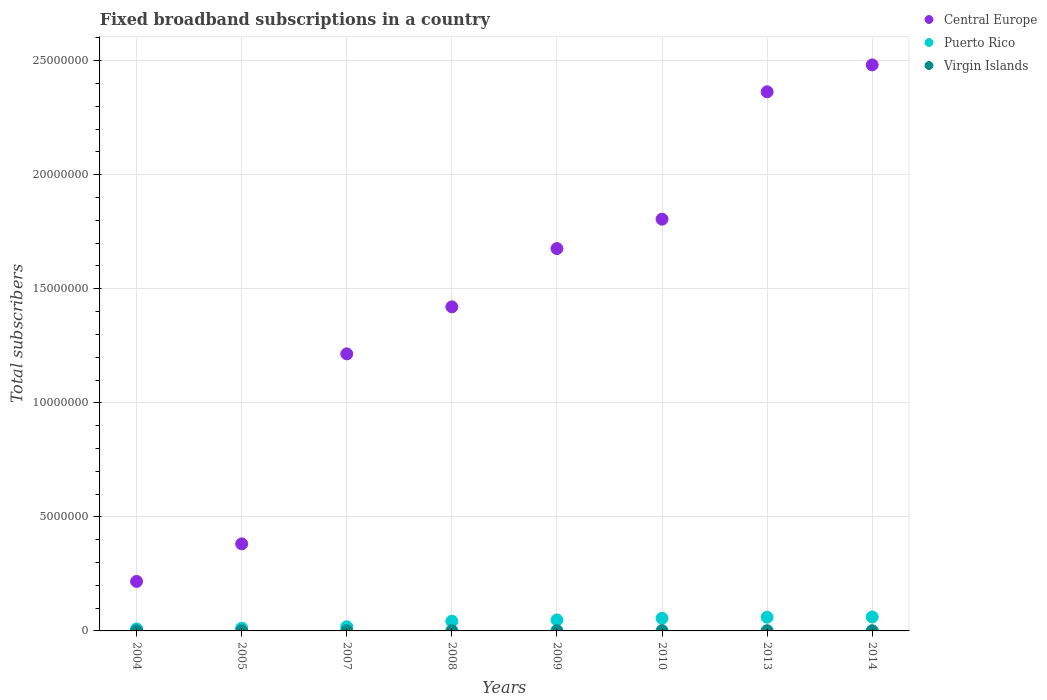Is the number of dotlines equal to the number of legend labels?
Keep it short and to the point. Yes. What is the number of broadband subscriptions in Central Europe in 2009?
Give a very brief answer. 1.68e+07. Across all years, what is the maximum number of broadband subscriptions in Virgin Islands?
Your answer should be compact. 9100. Across all years, what is the minimum number of broadband subscriptions in Central Europe?
Your answer should be compact. 2.17e+06. In which year was the number of broadband subscriptions in Puerto Rico maximum?
Ensure brevity in your answer.  2014. What is the total number of broadband subscriptions in Virgin Islands in the graph?
Ensure brevity in your answer.  5.41e+04. What is the difference between the number of broadband subscriptions in Virgin Islands in 2008 and that in 2009?
Your response must be concise. -1584. What is the difference between the number of broadband subscriptions in Central Europe in 2013 and the number of broadband subscriptions in Virgin Islands in 2007?
Make the answer very short. 2.36e+07. What is the average number of broadband subscriptions in Puerto Rico per year?
Your answer should be very brief. 3.82e+05. In the year 2004, what is the difference between the number of broadband subscriptions in Puerto Rico and number of broadband subscriptions in Central Europe?
Provide a short and direct response. -2.08e+06. In how many years, is the number of broadband subscriptions in Central Europe greater than 13000000?
Your answer should be compact. 5. What is the ratio of the number of broadband subscriptions in Virgin Islands in 2005 to that in 2008?
Provide a succinct answer. 0.4. Is the number of broadband subscriptions in Puerto Rico in 2007 less than that in 2014?
Ensure brevity in your answer.  Yes. Is the difference between the number of broadband subscriptions in Puerto Rico in 2009 and 2010 greater than the difference between the number of broadband subscriptions in Central Europe in 2009 and 2010?
Provide a succinct answer. Yes. What is the difference between the highest and the second highest number of broadband subscriptions in Central Europe?
Ensure brevity in your answer.  1.18e+06. What is the difference between the highest and the lowest number of broadband subscriptions in Virgin Islands?
Keep it short and to the point. 7616. In how many years, is the number of broadband subscriptions in Puerto Rico greater than the average number of broadband subscriptions in Puerto Rico taken over all years?
Your answer should be very brief. 5. Is it the case that in every year, the sum of the number of broadband subscriptions in Puerto Rico and number of broadband subscriptions in Central Europe  is greater than the number of broadband subscriptions in Virgin Islands?
Keep it short and to the point. Yes. Does the number of broadband subscriptions in Virgin Islands monotonically increase over the years?
Provide a succinct answer. No. Is the number of broadband subscriptions in Central Europe strictly greater than the number of broadband subscriptions in Puerto Rico over the years?
Offer a very short reply. Yes. Are the values on the major ticks of Y-axis written in scientific E-notation?
Your answer should be very brief. No. Does the graph contain grids?
Offer a terse response. Yes. How are the legend labels stacked?
Keep it short and to the point. Vertical. What is the title of the graph?
Make the answer very short. Fixed broadband subscriptions in a country. Does "Ireland" appear as one of the legend labels in the graph?
Keep it short and to the point. No. What is the label or title of the X-axis?
Your response must be concise. Years. What is the label or title of the Y-axis?
Make the answer very short. Total subscribers. What is the Total subscribers of Central Europe in 2004?
Your answer should be compact. 2.17e+06. What is the Total subscribers of Puerto Rico in 2004?
Your answer should be very brief. 8.63e+04. What is the Total subscribers of Virgin Islands in 2004?
Provide a short and direct response. 1484. What is the Total subscribers of Central Europe in 2005?
Make the answer very short. 3.82e+06. What is the Total subscribers of Puerto Rico in 2005?
Ensure brevity in your answer.  1.18e+05. What is the Total subscribers in Virgin Islands in 2005?
Make the answer very short. 2967. What is the Total subscribers of Central Europe in 2007?
Your answer should be very brief. 1.21e+07. What is the Total subscribers in Puerto Rico in 2007?
Your answer should be very brief. 1.82e+05. What is the Total subscribers in Virgin Islands in 2007?
Provide a succinct answer. 5933. What is the Total subscribers in Central Europe in 2008?
Offer a very short reply. 1.42e+07. What is the Total subscribers of Puerto Rico in 2008?
Offer a very short reply. 4.26e+05. What is the Total subscribers of Virgin Islands in 2008?
Give a very brief answer. 7416. What is the Total subscribers in Central Europe in 2009?
Keep it short and to the point. 1.68e+07. What is the Total subscribers in Puerto Rico in 2009?
Keep it short and to the point. 4.80e+05. What is the Total subscribers of Virgin Islands in 2009?
Your answer should be very brief. 9000. What is the Total subscribers in Central Europe in 2010?
Make the answer very short. 1.81e+07. What is the Total subscribers in Puerto Rico in 2010?
Offer a terse response. 5.52e+05. What is the Total subscribers in Virgin Islands in 2010?
Offer a terse response. 9100. What is the Total subscribers in Central Europe in 2013?
Offer a terse response. 2.36e+07. What is the Total subscribers in Puerto Rico in 2013?
Offer a terse response. 6.02e+05. What is the Total subscribers of Virgin Islands in 2013?
Your answer should be very brief. 9100. What is the Total subscribers of Central Europe in 2014?
Your response must be concise. 2.48e+07. What is the Total subscribers of Puerto Rico in 2014?
Provide a short and direct response. 6.10e+05. What is the Total subscribers of Virgin Islands in 2014?
Your response must be concise. 9100. Across all years, what is the maximum Total subscribers in Central Europe?
Provide a short and direct response. 2.48e+07. Across all years, what is the maximum Total subscribers in Puerto Rico?
Your response must be concise. 6.10e+05. Across all years, what is the maximum Total subscribers in Virgin Islands?
Make the answer very short. 9100. Across all years, what is the minimum Total subscribers in Central Europe?
Provide a short and direct response. 2.17e+06. Across all years, what is the minimum Total subscribers of Puerto Rico?
Your answer should be compact. 8.63e+04. Across all years, what is the minimum Total subscribers of Virgin Islands?
Your answer should be very brief. 1484. What is the total Total subscribers in Central Europe in the graph?
Ensure brevity in your answer.  1.16e+08. What is the total Total subscribers in Puerto Rico in the graph?
Your answer should be very brief. 3.06e+06. What is the total Total subscribers of Virgin Islands in the graph?
Your answer should be very brief. 5.41e+04. What is the difference between the Total subscribers in Central Europe in 2004 and that in 2005?
Offer a terse response. -1.65e+06. What is the difference between the Total subscribers in Puerto Rico in 2004 and that in 2005?
Your response must be concise. -3.20e+04. What is the difference between the Total subscribers of Virgin Islands in 2004 and that in 2005?
Ensure brevity in your answer.  -1483. What is the difference between the Total subscribers of Central Europe in 2004 and that in 2007?
Give a very brief answer. -9.98e+06. What is the difference between the Total subscribers in Puerto Rico in 2004 and that in 2007?
Provide a short and direct response. -9.59e+04. What is the difference between the Total subscribers of Virgin Islands in 2004 and that in 2007?
Ensure brevity in your answer.  -4449. What is the difference between the Total subscribers in Central Europe in 2004 and that in 2008?
Your answer should be compact. -1.20e+07. What is the difference between the Total subscribers in Puerto Rico in 2004 and that in 2008?
Your answer should be very brief. -3.40e+05. What is the difference between the Total subscribers of Virgin Islands in 2004 and that in 2008?
Your answer should be very brief. -5932. What is the difference between the Total subscribers of Central Europe in 2004 and that in 2009?
Offer a terse response. -1.46e+07. What is the difference between the Total subscribers in Puerto Rico in 2004 and that in 2009?
Provide a short and direct response. -3.94e+05. What is the difference between the Total subscribers in Virgin Islands in 2004 and that in 2009?
Your answer should be compact. -7516. What is the difference between the Total subscribers in Central Europe in 2004 and that in 2010?
Your answer should be very brief. -1.59e+07. What is the difference between the Total subscribers in Puerto Rico in 2004 and that in 2010?
Offer a very short reply. -4.65e+05. What is the difference between the Total subscribers in Virgin Islands in 2004 and that in 2010?
Make the answer very short. -7616. What is the difference between the Total subscribers of Central Europe in 2004 and that in 2013?
Offer a terse response. -2.15e+07. What is the difference between the Total subscribers of Puerto Rico in 2004 and that in 2013?
Provide a succinct answer. -5.15e+05. What is the difference between the Total subscribers in Virgin Islands in 2004 and that in 2013?
Give a very brief answer. -7616. What is the difference between the Total subscribers of Central Europe in 2004 and that in 2014?
Offer a terse response. -2.26e+07. What is the difference between the Total subscribers in Puerto Rico in 2004 and that in 2014?
Your response must be concise. -5.24e+05. What is the difference between the Total subscribers of Virgin Islands in 2004 and that in 2014?
Offer a very short reply. -7616. What is the difference between the Total subscribers of Central Europe in 2005 and that in 2007?
Make the answer very short. -8.33e+06. What is the difference between the Total subscribers of Puerto Rico in 2005 and that in 2007?
Give a very brief answer. -6.39e+04. What is the difference between the Total subscribers of Virgin Islands in 2005 and that in 2007?
Ensure brevity in your answer.  -2966. What is the difference between the Total subscribers in Central Europe in 2005 and that in 2008?
Ensure brevity in your answer.  -1.04e+07. What is the difference between the Total subscribers of Puerto Rico in 2005 and that in 2008?
Your answer should be compact. -3.08e+05. What is the difference between the Total subscribers of Virgin Islands in 2005 and that in 2008?
Offer a very short reply. -4449. What is the difference between the Total subscribers in Central Europe in 2005 and that in 2009?
Your answer should be very brief. -1.29e+07. What is the difference between the Total subscribers in Puerto Rico in 2005 and that in 2009?
Your answer should be compact. -3.62e+05. What is the difference between the Total subscribers in Virgin Islands in 2005 and that in 2009?
Your response must be concise. -6033. What is the difference between the Total subscribers of Central Europe in 2005 and that in 2010?
Give a very brief answer. -1.42e+07. What is the difference between the Total subscribers in Puerto Rico in 2005 and that in 2010?
Give a very brief answer. -4.33e+05. What is the difference between the Total subscribers of Virgin Islands in 2005 and that in 2010?
Provide a succinct answer. -6133. What is the difference between the Total subscribers in Central Europe in 2005 and that in 2013?
Ensure brevity in your answer.  -1.98e+07. What is the difference between the Total subscribers in Puerto Rico in 2005 and that in 2013?
Give a very brief answer. -4.83e+05. What is the difference between the Total subscribers in Virgin Islands in 2005 and that in 2013?
Provide a short and direct response. -6133. What is the difference between the Total subscribers of Central Europe in 2005 and that in 2014?
Give a very brief answer. -2.10e+07. What is the difference between the Total subscribers in Puerto Rico in 2005 and that in 2014?
Ensure brevity in your answer.  -4.92e+05. What is the difference between the Total subscribers of Virgin Islands in 2005 and that in 2014?
Offer a very short reply. -6133. What is the difference between the Total subscribers of Central Europe in 2007 and that in 2008?
Offer a terse response. -2.06e+06. What is the difference between the Total subscribers in Puerto Rico in 2007 and that in 2008?
Ensure brevity in your answer.  -2.44e+05. What is the difference between the Total subscribers of Virgin Islands in 2007 and that in 2008?
Make the answer very short. -1483. What is the difference between the Total subscribers in Central Europe in 2007 and that in 2009?
Offer a very short reply. -4.62e+06. What is the difference between the Total subscribers of Puerto Rico in 2007 and that in 2009?
Provide a short and direct response. -2.98e+05. What is the difference between the Total subscribers in Virgin Islands in 2007 and that in 2009?
Make the answer very short. -3067. What is the difference between the Total subscribers in Central Europe in 2007 and that in 2010?
Your answer should be compact. -5.90e+06. What is the difference between the Total subscribers of Puerto Rico in 2007 and that in 2010?
Offer a very short reply. -3.69e+05. What is the difference between the Total subscribers in Virgin Islands in 2007 and that in 2010?
Make the answer very short. -3167. What is the difference between the Total subscribers in Central Europe in 2007 and that in 2013?
Your answer should be very brief. -1.15e+07. What is the difference between the Total subscribers of Puerto Rico in 2007 and that in 2013?
Your response must be concise. -4.19e+05. What is the difference between the Total subscribers in Virgin Islands in 2007 and that in 2013?
Give a very brief answer. -3167. What is the difference between the Total subscribers of Central Europe in 2007 and that in 2014?
Give a very brief answer. -1.27e+07. What is the difference between the Total subscribers of Puerto Rico in 2007 and that in 2014?
Give a very brief answer. -4.28e+05. What is the difference between the Total subscribers in Virgin Islands in 2007 and that in 2014?
Your response must be concise. -3167. What is the difference between the Total subscribers in Central Europe in 2008 and that in 2009?
Give a very brief answer. -2.55e+06. What is the difference between the Total subscribers of Puerto Rico in 2008 and that in 2009?
Your response must be concise. -5.40e+04. What is the difference between the Total subscribers of Virgin Islands in 2008 and that in 2009?
Provide a short and direct response. -1584. What is the difference between the Total subscribers of Central Europe in 2008 and that in 2010?
Your answer should be very brief. -3.84e+06. What is the difference between the Total subscribers of Puerto Rico in 2008 and that in 2010?
Your answer should be very brief. -1.25e+05. What is the difference between the Total subscribers of Virgin Islands in 2008 and that in 2010?
Make the answer very short. -1684. What is the difference between the Total subscribers in Central Europe in 2008 and that in 2013?
Provide a short and direct response. -9.43e+06. What is the difference between the Total subscribers in Puerto Rico in 2008 and that in 2013?
Give a very brief answer. -1.75e+05. What is the difference between the Total subscribers of Virgin Islands in 2008 and that in 2013?
Make the answer very short. -1684. What is the difference between the Total subscribers of Central Europe in 2008 and that in 2014?
Ensure brevity in your answer.  -1.06e+07. What is the difference between the Total subscribers in Puerto Rico in 2008 and that in 2014?
Your answer should be compact. -1.84e+05. What is the difference between the Total subscribers of Virgin Islands in 2008 and that in 2014?
Keep it short and to the point. -1684. What is the difference between the Total subscribers of Central Europe in 2009 and that in 2010?
Your answer should be compact. -1.29e+06. What is the difference between the Total subscribers in Puerto Rico in 2009 and that in 2010?
Your response must be concise. -7.12e+04. What is the difference between the Total subscribers in Virgin Islands in 2009 and that in 2010?
Your response must be concise. -100. What is the difference between the Total subscribers of Central Europe in 2009 and that in 2013?
Ensure brevity in your answer.  -6.87e+06. What is the difference between the Total subscribers of Puerto Rico in 2009 and that in 2013?
Offer a very short reply. -1.21e+05. What is the difference between the Total subscribers of Virgin Islands in 2009 and that in 2013?
Offer a very short reply. -100. What is the difference between the Total subscribers in Central Europe in 2009 and that in 2014?
Make the answer very short. -8.05e+06. What is the difference between the Total subscribers in Puerto Rico in 2009 and that in 2014?
Ensure brevity in your answer.  -1.30e+05. What is the difference between the Total subscribers of Virgin Islands in 2009 and that in 2014?
Provide a succinct answer. -100. What is the difference between the Total subscribers in Central Europe in 2010 and that in 2013?
Your answer should be compact. -5.59e+06. What is the difference between the Total subscribers of Puerto Rico in 2010 and that in 2013?
Your response must be concise. -5.00e+04. What is the difference between the Total subscribers in Central Europe in 2010 and that in 2014?
Provide a short and direct response. -6.77e+06. What is the difference between the Total subscribers of Puerto Rico in 2010 and that in 2014?
Your answer should be compact. -5.88e+04. What is the difference between the Total subscribers in Central Europe in 2013 and that in 2014?
Offer a very short reply. -1.18e+06. What is the difference between the Total subscribers of Puerto Rico in 2013 and that in 2014?
Provide a succinct answer. -8764. What is the difference between the Total subscribers of Virgin Islands in 2013 and that in 2014?
Make the answer very short. 0. What is the difference between the Total subscribers in Central Europe in 2004 and the Total subscribers in Puerto Rico in 2005?
Make the answer very short. 2.05e+06. What is the difference between the Total subscribers of Central Europe in 2004 and the Total subscribers of Virgin Islands in 2005?
Provide a short and direct response. 2.17e+06. What is the difference between the Total subscribers of Puerto Rico in 2004 and the Total subscribers of Virgin Islands in 2005?
Make the answer very short. 8.33e+04. What is the difference between the Total subscribers in Central Europe in 2004 and the Total subscribers in Puerto Rico in 2007?
Provide a short and direct response. 1.99e+06. What is the difference between the Total subscribers in Central Europe in 2004 and the Total subscribers in Virgin Islands in 2007?
Offer a very short reply. 2.16e+06. What is the difference between the Total subscribers of Puerto Rico in 2004 and the Total subscribers of Virgin Islands in 2007?
Offer a very short reply. 8.04e+04. What is the difference between the Total subscribers of Central Europe in 2004 and the Total subscribers of Puerto Rico in 2008?
Ensure brevity in your answer.  1.74e+06. What is the difference between the Total subscribers of Central Europe in 2004 and the Total subscribers of Virgin Islands in 2008?
Provide a succinct answer. 2.16e+06. What is the difference between the Total subscribers in Puerto Rico in 2004 and the Total subscribers in Virgin Islands in 2008?
Make the answer very short. 7.89e+04. What is the difference between the Total subscribers of Central Europe in 2004 and the Total subscribers of Puerto Rico in 2009?
Offer a very short reply. 1.69e+06. What is the difference between the Total subscribers in Central Europe in 2004 and the Total subscribers in Virgin Islands in 2009?
Give a very brief answer. 2.16e+06. What is the difference between the Total subscribers of Puerto Rico in 2004 and the Total subscribers of Virgin Islands in 2009?
Offer a very short reply. 7.73e+04. What is the difference between the Total subscribers of Central Europe in 2004 and the Total subscribers of Puerto Rico in 2010?
Ensure brevity in your answer.  1.62e+06. What is the difference between the Total subscribers of Central Europe in 2004 and the Total subscribers of Virgin Islands in 2010?
Give a very brief answer. 2.16e+06. What is the difference between the Total subscribers in Puerto Rico in 2004 and the Total subscribers in Virgin Islands in 2010?
Your response must be concise. 7.72e+04. What is the difference between the Total subscribers of Central Europe in 2004 and the Total subscribers of Puerto Rico in 2013?
Offer a very short reply. 1.57e+06. What is the difference between the Total subscribers of Central Europe in 2004 and the Total subscribers of Virgin Islands in 2013?
Your answer should be very brief. 2.16e+06. What is the difference between the Total subscribers of Puerto Rico in 2004 and the Total subscribers of Virgin Islands in 2013?
Provide a succinct answer. 7.72e+04. What is the difference between the Total subscribers in Central Europe in 2004 and the Total subscribers in Puerto Rico in 2014?
Provide a succinct answer. 1.56e+06. What is the difference between the Total subscribers of Central Europe in 2004 and the Total subscribers of Virgin Islands in 2014?
Your answer should be compact. 2.16e+06. What is the difference between the Total subscribers in Puerto Rico in 2004 and the Total subscribers in Virgin Islands in 2014?
Keep it short and to the point. 7.72e+04. What is the difference between the Total subscribers of Central Europe in 2005 and the Total subscribers of Puerto Rico in 2007?
Make the answer very short. 3.63e+06. What is the difference between the Total subscribers in Central Europe in 2005 and the Total subscribers in Virgin Islands in 2007?
Your response must be concise. 3.81e+06. What is the difference between the Total subscribers in Puerto Rico in 2005 and the Total subscribers in Virgin Islands in 2007?
Your answer should be very brief. 1.12e+05. What is the difference between the Total subscribers of Central Europe in 2005 and the Total subscribers of Puerto Rico in 2008?
Provide a short and direct response. 3.39e+06. What is the difference between the Total subscribers of Central Europe in 2005 and the Total subscribers of Virgin Islands in 2008?
Offer a very short reply. 3.81e+06. What is the difference between the Total subscribers in Puerto Rico in 2005 and the Total subscribers in Virgin Islands in 2008?
Provide a short and direct response. 1.11e+05. What is the difference between the Total subscribers in Central Europe in 2005 and the Total subscribers in Puerto Rico in 2009?
Provide a short and direct response. 3.34e+06. What is the difference between the Total subscribers of Central Europe in 2005 and the Total subscribers of Virgin Islands in 2009?
Ensure brevity in your answer.  3.81e+06. What is the difference between the Total subscribers in Puerto Rico in 2005 and the Total subscribers in Virgin Islands in 2009?
Provide a succinct answer. 1.09e+05. What is the difference between the Total subscribers in Central Europe in 2005 and the Total subscribers in Puerto Rico in 2010?
Your answer should be compact. 3.27e+06. What is the difference between the Total subscribers in Central Europe in 2005 and the Total subscribers in Virgin Islands in 2010?
Provide a succinct answer. 3.81e+06. What is the difference between the Total subscribers in Puerto Rico in 2005 and the Total subscribers in Virgin Islands in 2010?
Your answer should be compact. 1.09e+05. What is the difference between the Total subscribers of Central Europe in 2005 and the Total subscribers of Puerto Rico in 2013?
Your answer should be compact. 3.22e+06. What is the difference between the Total subscribers of Central Europe in 2005 and the Total subscribers of Virgin Islands in 2013?
Your answer should be very brief. 3.81e+06. What is the difference between the Total subscribers of Puerto Rico in 2005 and the Total subscribers of Virgin Islands in 2013?
Your answer should be very brief. 1.09e+05. What is the difference between the Total subscribers in Central Europe in 2005 and the Total subscribers in Puerto Rico in 2014?
Your answer should be very brief. 3.21e+06. What is the difference between the Total subscribers in Central Europe in 2005 and the Total subscribers in Virgin Islands in 2014?
Give a very brief answer. 3.81e+06. What is the difference between the Total subscribers of Puerto Rico in 2005 and the Total subscribers of Virgin Islands in 2014?
Make the answer very short. 1.09e+05. What is the difference between the Total subscribers in Central Europe in 2007 and the Total subscribers in Puerto Rico in 2008?
Provide a short and direct response. 1.17e+07. What is the difference between the Total subscribers of Central Europe in 2007 and the Total subscribers of Virgin Islands in 2008?
Your answer should be very brief. 1.21e+07. What is the difference between the Total subscribers in Puerto Rico in 2007 and the Total subscribers in Virgin Islands in 2008?
Offer a very short reply. 1.75e+05. What is the difference between the Total subscribers in Central Europe in 2007 and the Total subscribers in Puerto Rico in 2009?
Ensure brevity in your answer.  1.17e+07. What is the difference between the Total subscribers of Central Europe in 2007 and the Total subscribers of Virgin Islands in 2009?
Provide a short and direct response. 1.21e+07. What is the difference between the Total subscribers in Puerto Rico in 2007 and the Total subscribers in Virgin Islands in 2009?
Keep it short and to the point. 1.73e+05. What is the difference between the Total subscribers in Central Europe in 2007 and the Total subscribers in Puerto Rico in 2010?
Provide a succinct answer. 1.16e+07. What is the difference between the Total subscribers of Central Europe in 2007 and the Total subscribers of Virgin Islands in 2010?
Provide a short and direct response. 1.21e+07. What is the difference between the Total subscribers in Puerto Rico in 2007 and the Total subscribers in Virgin Islands in 2010?
Give a very brief answer. 1.73e+05. What is the difference between the Total subscribers of Central Europe in 2007 and the Total subscribers of Puerto Rico in 2013?
Ensure brevity in your answer.  1.15e+07. What is the difference between the Total subscribers of Central Europe in 2007 and the Total subscribers of Virgin Islands in 2013?
Provide a succinct answer. 1.21e+07. What is the difference between the Total subscribers of Puerto Rico in 2007 and the Total subscribers of Virgin Islands in 2013?
Your answer should be very brief. 1.73e+05. What is the difference between the Total subscribers of Central Europe in 2007 and the Total subscribers of Puerto Rico in 2014?
Make the answer very short. 1.15e+07. What is the difference between the Total subscribers of Central Europe in 2007 and the Total subscribers of Virgin Islands in 2014?
Your answer should be compact. 1.21e+07. What is the difference between the Total subscribers of Puerto Rico in 2007 and the Total subscribers of Virgin Islands in 2014?
Your response must be concise. 1.73e+05. What is the difference between the Total subscribers in Central Europe in 2008 and the Total subscribers in Puerto Rico in 2009?
Give a very brief answer. 1.37e+07. What is the difference between the Total subscribers of Central Europe in 2008 and the Total subscribers of Virgin Islands in 2009?
Offer a very short reply. 1.42e+07. What is the difference between the Total subscribers of Puerto Rico in 2008 and the Total subscribers of Virgin Islands in 2009?
Ensure brevity in your answer.  4.17e+05. What is the difference between the Total subscribers in Central Europe in 2008 and the Total subscribers in Puerto Rico in 2010?
Provide a succinct answer. 1.37e+07. What is the difference between the Total subscribers of Central Europe in 2008 and the Total subscribers of Virgin Islands in 2010?
Give a very brief answer. 1.42e+07. What is the difference between the Total subscribers of Puerto Rico in 2008 and the Total subscribers of Virgin Islands in 2010?
Provide a short and direct response. 4.17e+05. What is the difference between the Total subscribers of Central Europe in 2008 and the Total subscribers of Puerto Rico in 2013?
Provide a succinct answer. 1.36e+07. What is the difference between the Total subscribers of Central Europe in 2008 and the Total subscribers of Virgin Islands in 2013?
Give a very brief answer. 1.42e+07. What is the difference between the Total subscribers in Puerto Rico in 2008 and the Total subscribers in Virgin Islands in 2013?
Give a very brief answer. 4.17e+05. What is the difference between the Total subscribers in Central Europe in 2008 and the Total subscribers in Puerto Rico in 2014?
Provide a succinct answer. 1.36e+07. What is the difference between the Total subscribers in Central Europe in 2008 and the Total subscribers in Virgin Islands in 2014?
Offer a very short reply. 1.42e+07. What is the difference between the Total subscribers of Puerto Rico in 2008 and the Total subscribers of Virgin Islands in 2014?
Your answer should be compact. 4.17e+05. What is the difference between the Total subscribers of Central Europe in 2009 and the Total subscribers of Puerto Rico in 2010?
Offer a terse response. 1.62e+07. What is the difference between the Total subscribers in Central Europe in 2009 and the Total subscribers in Virgin Islands in 2010?
Provide a short and direct response. 1.68e+07. What is the difference between the Total subscribers of Puerto Rico in 2009 and the Total subscribers of Virgin Islands in 2010?
Make the answer very short. 4.71e+05. What is the difference between the Total subscribers in Central Europe in 2009 and the Total subscribers in Puerto Rico in 2013?
Your response must be concise. 1.62e+07. What is the difference between the Total subscribers of Central Europe in 2009 and the Total subscribers of Virgin Islands in 2013?
Offer a terse response. 1.68e+07. What is the difference between the Total subscribers of Puerto Rico in 2009 and the Total subscribers of Virgin Islands in 2013?
Provide a short and direct response. 4.71e+05. What is the difference between the Total subscribers of Central Europe in 2009 and the Total subscribers of Puerto Rico in 2014?
Offer a terse response. 1.62e+07. What is the difference between the Total subscribers of Central Europe in 2009 and the Total subscribers of Virgin Islands in 2014?
Give a very brief answer. 1.68e+07. What is the difference between the Total subscribers of Puerto Rico in 2009 and the Total subscribers of Virgin Islands in 2014?
Ensure brevity in your answer.  4.71e+05. What is the difference between the Total subscribers of Central Europe in 2010 and the Total subscribers of Puerto Rico in 2013?
Offer a terse response. 1.75e+07. What is the difference between the Total subscribers of Central Europe in 2010 and the Total subscribers of Virgin Islands in 2013?
Keep it short and to the point. 1.80e+07. What is the difference between the Total subscribers in Puerto Rico in 2010 and the Total subscribers in Virgin Islands in 2013?
Give a very brief answer. 5.42e+05. What is the difference between the Total subscribers in Central Europe in 2010 and the Total subscribers in Puerto Rico in 2014?
Your answer should be very brief. 1.74e+07. What is the difference between the Total subscribers of Central Europe in 2010 and the Total subscribers of Virgin Islands in 2014?
Make the answer very short. 1.80e+07. What is the difference between the Total subscribers of Puerto Rico in 2010 and the Total subscribers of Virgin Islands in 2014?
Offer a terse response. 5.42e+05. What is the difference between the Total subscribers in Central Europe in 2013 and the Total subscribers in Puerto Rico in 2014?
Provide a short and direct response. 2.30e+07. What is the difference between the Total subscribers in Central Europe in 2013 and the Total subscribers in Virgin Islands in 2014?
Your answer should be very brief. 2.36e+07. What is the difference between the Total subscribers of Puerto Rico in 2013 and the Total subscribers of Virgin Islands in 2014?
Make the answer very short. 5.92e+05. What is the average Total subscribers in Central Europe per year?
Provide a succinct answer. 1.45e+07. What is the average Total subscribers of Puerto Rico per year?
Ensure brevity in your answer.  3.82e+05. What is the average Total subscribers in Virgin Islands per year?
Offer a terse response. 6762.5. In the year 2004, what is the difference between the Total subscribers in Central Europe and Total subscribers in Puerto Rico?
Ensure brevity in your answer.  2.08e+06. In the year 2004, what is the difference between the Total subscribers in Central Europe and Total subscribers in Virgin Islands?
Provide a succinct answer. 2.17e+06. In the year 2004, what is the difference between the Total subscribers in Puerto Rico and Total subscribers in Virgin Islands?
Make the answer very short. 8.48e+04. In the year 2005, what is the difference between the Total subscribers in Central Europe and Total subscribers in Puerto Rico?
Make the answer very short. 3.70e+06. In the year 2005, what is the difference between the Total subscribers in Central Europe and Total subscribers in Virgin Islands?
Keep it short and to the point. 3.81e+06. In the year 2005, what is the difference between the Total subscribers of Puerto Rico and Total subscribers of Virgin Islands?
Ensure brevity in your answer.  1.15e+05. In the year 2007, what is the difference between the Total subscribers of Central Europe and Total subscribers of Puerto Rico?
Make the answer very short. 1.20e+07. In the year 2007, what is the difference between the Total subscribers of Central Europe and Total subscribers of Virgin Islands?
Keep it short and to the point. 1.21e+07. In the year 2007, what is the difference between the Total subscribers of Puerto Rico and Total subscribers of Virgin Islands?
Offer a terse response. 1.76e+05. In the year 2008, what is the difference between the Total subscribers of Central Europe and Total subscribers of Puerto Rico?
Provide a short and direct response. 1.38e+07. In the year 2008, what is the difference between the Total subscribers of Central Europe and Total subscribers of Virgin Islands?
Offer a very short reply. 1.42e+07. In the year 2008, what is the difference between the Total subscribers in Puerto Rico and Total subscribers in Virgin Islands?
Provide a short and direct response. 4.19e+05. In the year 2009, what is the difference between the Total subscribers of Central Europe and Total subscribers of Puerto Rico?
Your answer should be very brief. 1.63e+07. In the year 2009, what is the difference between the Total subscribers of Central Europe and Total subscribers of Virgin Islands?
Offer a very short reply. 1.68e+07. In the year 2009, what is the difference between the Total subscribers in Puerto Rico and Total subscribers in Virgin Islands?
Offer a terse response. 4.71e+05. In the year 2010, what is the difference between the Total subscribers of Central Europe and Total subscribers of Puerto Rico?
Ensure brevity in your answer.  1.75e+07. In the year 2010, what is the difference between the Total subscribers in Central Europe and Total subscribers in Virgin Islands?
Make the answer very short. 1.80e+07. In the year 2010, what is the difference between the Total subscribers in Puerto Rico and Total subscribers in Virgin Islands?
Your response must be concise. 5.42e+05. In the year 2013, what is the difference between the Total subscribers in Central Europe and Total subscribers in Puerto Rico?
Provide a short and direct response. 2.30e+07. In the year 2013, what is the difference between the Total subscribers in Central Europe and Total subscribers in Virgin Islands?
Offer a terse response. 2.36e+07. In the year 2013, what is the difference between the Total subscribers of Puerto Rico and Total subscribers of Virgin Islands?
Ensure brevity in your answer.  5.92e+05. In the year 2014, what is the difference between the Total subscribers in Central Europe and Total subscribers in Puerto Rico?
Your answer should be compact. 2.42e+07. In the year 2014, what is the difference between the Total subscribers of Central Europe and Total subscribers of Virgin Islands?
Provide a succinct answer. 2.48e+07. In the year 2014, what is the difference between the Total subscribers in Puerto Rico and Total subscribers in Virgin Islands?
Provide a short and direct response. 6.01e+05. What is the ratio of the Total subscribers in Central Europe in 2004 to that in 2005?
Ensure brevity in your answer.  0.57. What is the ratio of the Total subscribers of Puerto Rico in 2004 to that in 2005?
Your response must be concise. 0.73. What is the ratio of the Total subscribers of Virgin Islands in 2004 to that in 2005?
Give a very brief answer. 0.5. What is the ratio of the Total subscribers of Central Europe in 2004 to that in 2007?
Your answer should be very brief. 0.18. What is the ratio of the Total subscribers in Puerto Rico in 2004 to that in 2007?
Your answer should be very brief. 0.47. What is the ratio of the Total subscribers in Virgin Islands in 2004 to that in 2007?
Provide a short and direct response. 0.25. What is the ratio of the Total subscribers in Central Europe in 2004 to that in 2008?
Provide a short and direct response. 0.15. What is the ratio of the Total subscribers of Puerto Rico in 2004 to that in 2008?
Offer a terse response. 0.2. What is the ratio of the Total subscribers in Virgin Islands in 2004 to that in 2008?
Provide a succinct answer. 0.2. What is the ratio of the Total subscribers of Central Europe in 2004 to that in 2009?
Your response must be concise. 0.13. What is the ratio of the Total subscribers in Puerto Rico in 2004 to that in 2009?
Keep it short and to the point. 0.18. What is the ratio of the Total subscribers of Virgin Islands in 2004 to that in 2009?
Your answer should be compact. 0.16. What is the ratio of the Total subscribers of Central Europe in 2004 to that in 2010?
Ensure brevity in your answer.  0.12. What is the ratio of the Total subscribers of Puerto Rico in 2004 to that in 2010?
Give a very brief answer. 0.16. What is the ratio of the Total subscribers in Virgin Islands in 2004 to that in 2010?
Your answer should be very brief. 0.16. What is the ratio of the Total subscribers of Central Europe in 2004 to that in 2013?
Your response must be concise. 0.09. What is the ratio of the Total subscribers in Puerto Rico in 2004 to that in 2013?
Offer a very short reply. 0.14. What is the ratio of the Total subscribers of Virgin Islands in 2004 to that in 2013?
Keep it short and to the point. 0.16. What is the ratio of the Total subscribers of Central Europe in 2004 to that in 2014?
Ensure brevity in your answer.  0.09. What is the ratio of the Total subscribers in Puerto Rico in 2004 to that in 2014?
Provide a succinct answer. 0.14. What is the ratio of the Total subscribers of Virgin Islands in 2004 to that in 2014?
Your response must be concise. 0.16. What is the ratio of the Total subscribers of Central Europe in 2005 to that in 2007?
Your answer should be compact. 0.31. What is the ratio of the Total subscribers in Puerto Rico in 2005 to that in 2007?
Provide a succinct answer. 0.65. What is the ratio of the Total subscribers of Virgin Islands in 2005 to that in 2007?
Keep it short and to the point. 0.5. What is the ratio of the Total subscribers of Central Europe in 2005 to that in 2008?
Your response must be concise. 0.27. What is the ratio of the Total subscribers of Puerto Rico in 2005 to that in 2008?
Offer a very short reply. 0.28. What is the ratio of the Total subscribers in Virgin Islands in 2005 to that in 2008?
Make the answer very short. 0.4. What is the ratio of the Total subscribers in Central Europe in 2005 to that in 2009?
Provide a succinct answer. 0.23. What is the ratio of the Total subscribers in Puerto Rico in 2005 to that in 2009?
Offer a terse response. 0.25. What is the ratio of the Total subscribers of Virgin Islands in 2005 to that in 2009?
Your answer should be very brief. 0.33. What is the ratio of the Total subscribers in Central Europe in 2005 to that in 2010?
Your answer should be compact. 0.21. What is the ratio of the Total subscribers of Puerto Rico in 2005 to that in 2010?
Your answer should be very brief. 0.21. What is the ratio of the Total subscribers in Virgin Islands in 2005 to that in 2010?
Give a very brief answer. 0.33. What is the ratio of the Total subscribers of Central Europe in 2005 to that in 2013?
Keep it short and to the point. 0.16. What is the ratio of the Total subscribers of Puerto Rico in 2005 to that in 2013?
Keep it short and to the point. 0.2. What is the ratio of the Total subscribers of Virgin Islands in 2005 to that in 2013?
Provide a succinct answer. 0.33. What is the ratio of the Total subscribers in Central Europe in 2005 to that in 2014?
Offer a terse response. 0.15. What is the ratio of the Total subscribers of Puerto Rico in 2005 to that in 2014?
Offer a terse response. 0.19. What is the ratio of the Total subscribers in Virgin Islands in 2005 to that in 2014?
Provide a succinct answer. 0.33. What is the ratio of the Total subscribers in Central Europe in 2007 to that in 2008?
Keep it short and to the point. 0.85. What is the ratio of the Total subscribers of Puerto Rico in 2007 to that in 2008?
Provide a short and direct response. 0.43. What is the ratio of the Total subscribers in Virgin Islands in 2007 to that in 2008?
Your answer should be very brief. 0.8. What is the ratio of the Total subscribers in Central Europe in 2007 to that in 2009?
Provide a short and direct response. 0.72. What is the ratio of the Total subscribers of Puerto Rico in 2007 to that in 2009?
Your answer should be very brief. 0.38. What is the ratio of the Total subscribers of Virgin Islands in 2007 to that in 2009?
Provide a succinct answer. 0.66. What is the ratio of the Total subscribers of Central Europe in 2007 to that in 2010?
Your response must be concise. 0.67. What is the ratio of the Total subscribers in Puerto Rico in 2007 to that in 2010?
Make the answer very short. 0.33. What is the ratio of the Total subscribers of Virgin Islands in 2007 to that in 2010?
Provide a succinct answer. 0.65. What is the ratio of the Total subscribers in Central Europe in 2007 to that in 2013?
Your answer should be compact. 0.51. What is the ratio of the Total subscribers of Puerto Rico in 2007 to that in 2013?
Your answer should be very brief. 0.3. What is the ratio of the Total subscribers of Virgin Islands in 2007 to that in 2013?
Keep it short and to the point. 0.65. What is the ratio of the Total subscribers of Central Europe in 2007 to that in 2014?
Offer a very short reply. 0.49. What is the ratio of the Total subscribers in Puerto Rico in 2007 to that in 2014?
Provide a succinct answer. 0.3. What is the ratio of the Total subscribers in Virgin Islands in 2007 to that in 2014?
Offer a terse response. 0.65. What is the ratio of the Total subscribers of Central Europe in 2008 to that in 2009?
Your answer should be compact. 0.85. What is the ratio of the Total subscribers in Puerto Rico in 2008 to that in 2009?
Offer a terse response. 0.89. What is the ratio of the Total subscribers of Virgin Islands in 2008 to that in 2009?
Provide a succinct answer. 0.82. What is the ratio of the Total subscribers in Central Europe in 2008 to that in 2010?
Make the answer very short. 0.79. What is the ratio of the Total subscribers of Puerto Rico in 2008 to that in 2010?
Keep it short and to the point. 0.77. What is the ratio of the Total subscribers of Virgin Islands in 2008 to that in 2010?
Keep it short and to the point. 0.81. What is the ratio of the Total subscribers in Central Europe in 2008 to that in 2013?
Provide a succinct answer. 0.6. What is the ratio of the Total subscribers in Puerto Rico in 2008 to that in 2013?
Your answer should be compact. 0.71. What is the ratio of the Total subscribers in Virgin Islands in 2008 to that in 2013?
Your answer should be compact. 0.81. What is the ratio of the Total subscribers of Central Europe in 2008 to that in 2014?
Your response must be concise. 0.57. What is the ratio of the Total subscribers in Puerto Rico in 2008 to that in 2014?
Offer a terse response. 0.7. What is the ratio of the Total subscribers of Virgin Islands in 2008 to that in 2014?
Your response must be concise. 0.81. What is the ratio of the Total subscribers in Puerto Rico in 2009 to that in 2010?
Provide a succinct answer. 0.87. What is the ratio of the Total subscribers of Central Europe in 2009 to that in 2013?
Provide a short and direct response. 0.71. What is the ratio of the Total subscribers of Puerto Rico in 2009 to that in 2013?
Your answer should be compact. 0.8. What is the ratio of the Total subscribers of Virgin Islands in 2009 to that in 2013?
Keep it short and to the point. 0.99. What is the ratio of the Total subscribers of Central Europe in 2009 to that in 2014?
Give a very brief answer. 0.68. What is the ratio of the Total subscribers in Puerto Rico in 2009 to that in 2014?
Your answer should be very brief. 0.79. What is the ratio of the Total subscribers of Virgin Islands in 2009 to that in 2014?
Your response must be concise. 0.99. What is the ratio of the Total subscribers in Central Europe in 2010 to that in 2013?
Keep it short and to the point. 0.76. What is the ratio of the Total subscribers in Puerto Rico in 2010 to that in 2013?
Offer a terse response. 0.92. What is the ratio of the Total subscribers of Virgin Islands in 2010 to that in 2013?
Your response must be concise. 1. What is the ratio of the Total subscribers in Central Europe in 2010 to that in 2014?
Ensure brevity in your answer.  0.73. What is the ratio of the Total subscribers in Puerto Rico in 2010 to that in 2014?
Offer a very short reply. 0.9. What is the ratio of the Total subscribers of Virgin Islands in 2010 to that in 2014?
Your response must be concise. 1. What is the ratio of the Total subscribers in Puerto Rico in 2013 to that in 2014?
Your response must be concise. 0.99. What is the difference between the highest and the second highest Total subscribers of Central Europe?
Keep it short and to the point. 1.18e+06. What is the difference between the highest and the second highest Total subscribers in Puerto Rico?
Your answer should be very brief. 8764. What is the difference between the highest and the lowest Total subscribers of Central Europe?
Provide a short and direct response. 2.26e+07. What is the difference between the highest and the lowest Total subscribers in Puerto Rico?
Your response must be concise. 5.24e+05. What is the difference between the highest and the lowest Total subscribers of Virgin Islands?
Your response must be concise. 7616. 